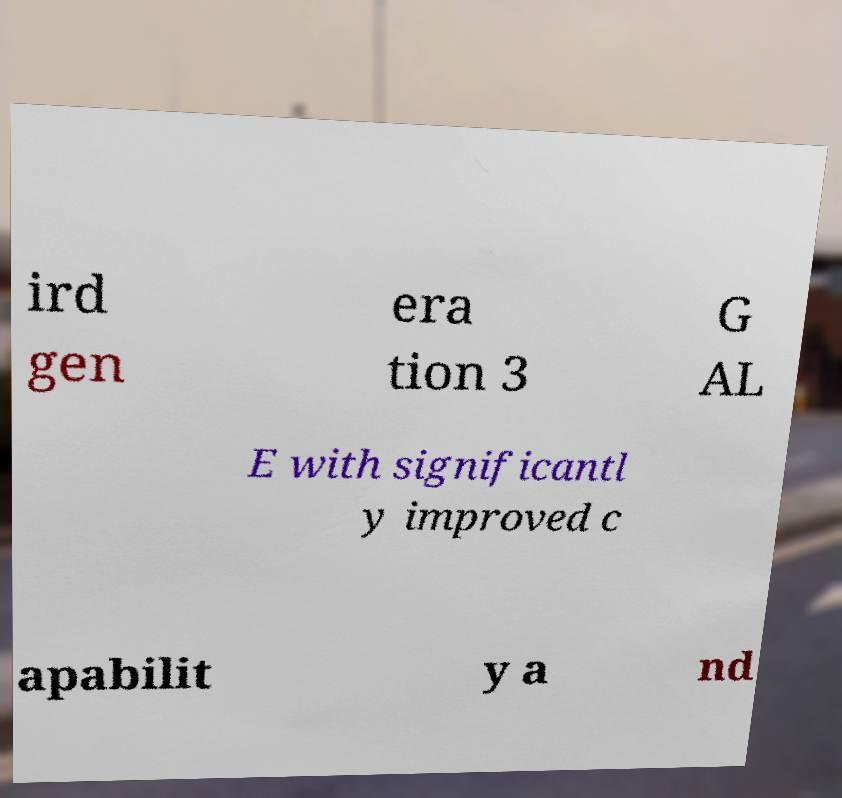I need the written content from this picture converted into text. Can you do that? ird gen era tion 3 G AL E with significantl y improved c apabilit y a nd 